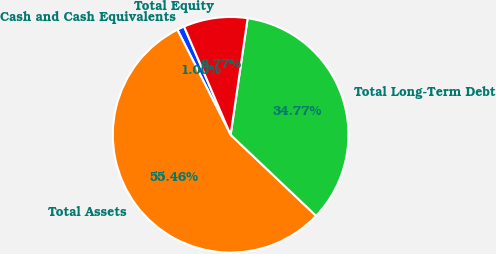Convert chart to OTSL. <chart><loc_0><loc_0><loc_500><loc_500><pie_chart><fcel>Cash and Cash Equivalents<fcel>Total Assets<fcel>Total Long-Term Debt<fcel>Total Equity<nl><fcel>1.0%<fcel>55.46%<fcel>34.77%<fcel>8.77%<nl></chart> 